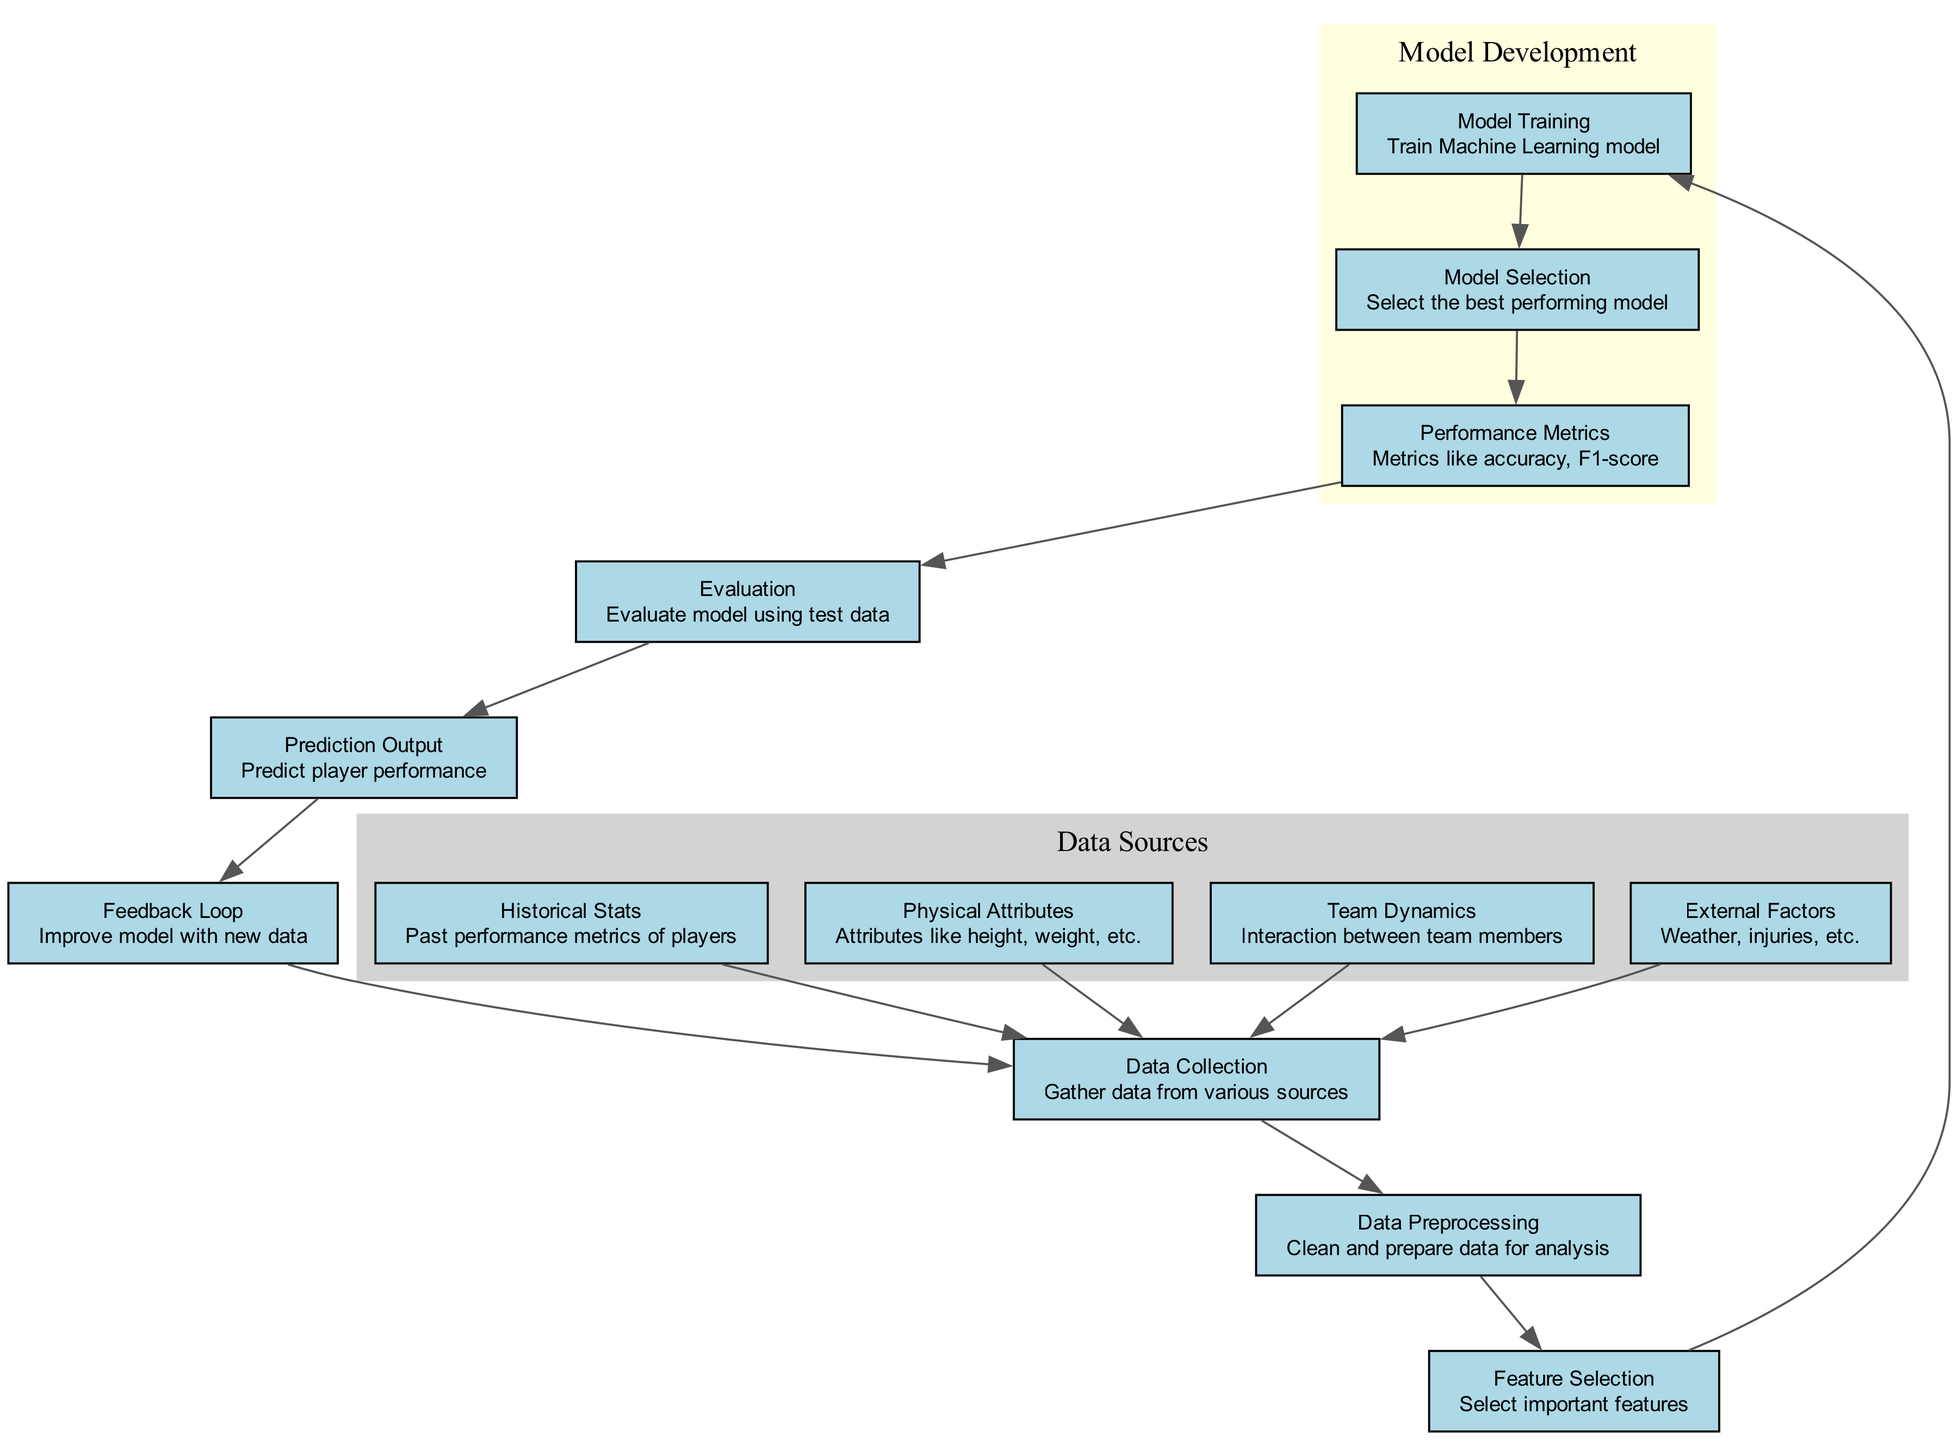What is the first step in the diagram? The first step in the diagram is the "Data Collection" node. This node is connected to several data sources including historical stats, physical attributes, team dynamics, and external factors, indicating that data collection initiates the process.
Answer: Data Collection How many nodes are in the diagram? There are 13 nodes in the diagram, including all the various steps and components mentioned. This includes data inputs, processing elements, and the model outputs.
Answer: 13 What does the "Feedback Loop" node connect to? The "Feedback Loop" node connects back to the "Data Collection" node. This indicates a cyclical process where new data can reinform the collection stage to improve future predictions.
Answer: Data Collection How many edges are there in total between the nodes? There are 12 edges in total, which represent the connections and flow of information between the various nodes in the diagram. Each edge corresponds to a relationship or step in the process.
Answer: 12 Which node evaluates the model's performance? The "Evaluation" node evaluates the model's performance. It is connected to the "Performance Metrics" node, indicating that quality assessments and metrics are analyzed here to determine model effectiveness.
Answer: Evaluation What is the last step in the diagram before producing outputs? The last step before producing outputs is the "Evaluation" node, which assesses the trained model's efficacy based on test data prior to generating any predictions of player performance.
Answer: Evaluation Which node serves as input for feature selection? The "Data Preprocessing" node serves as input for "Feature Selection." This indicates that after data cleaning and preparation, the most relevant features are selected for model training.
Answer: Data Preprocessing What do the nodes "Model Training" and "Model Selection" have in common? Both the "Model Training" and "Model Selection" nodes are part of the "Model Development" cluster in the diagram. They are interconnected as the training of the model directly leads to the selection of the best performing model based on performance metrics.
Answer: Model Development 